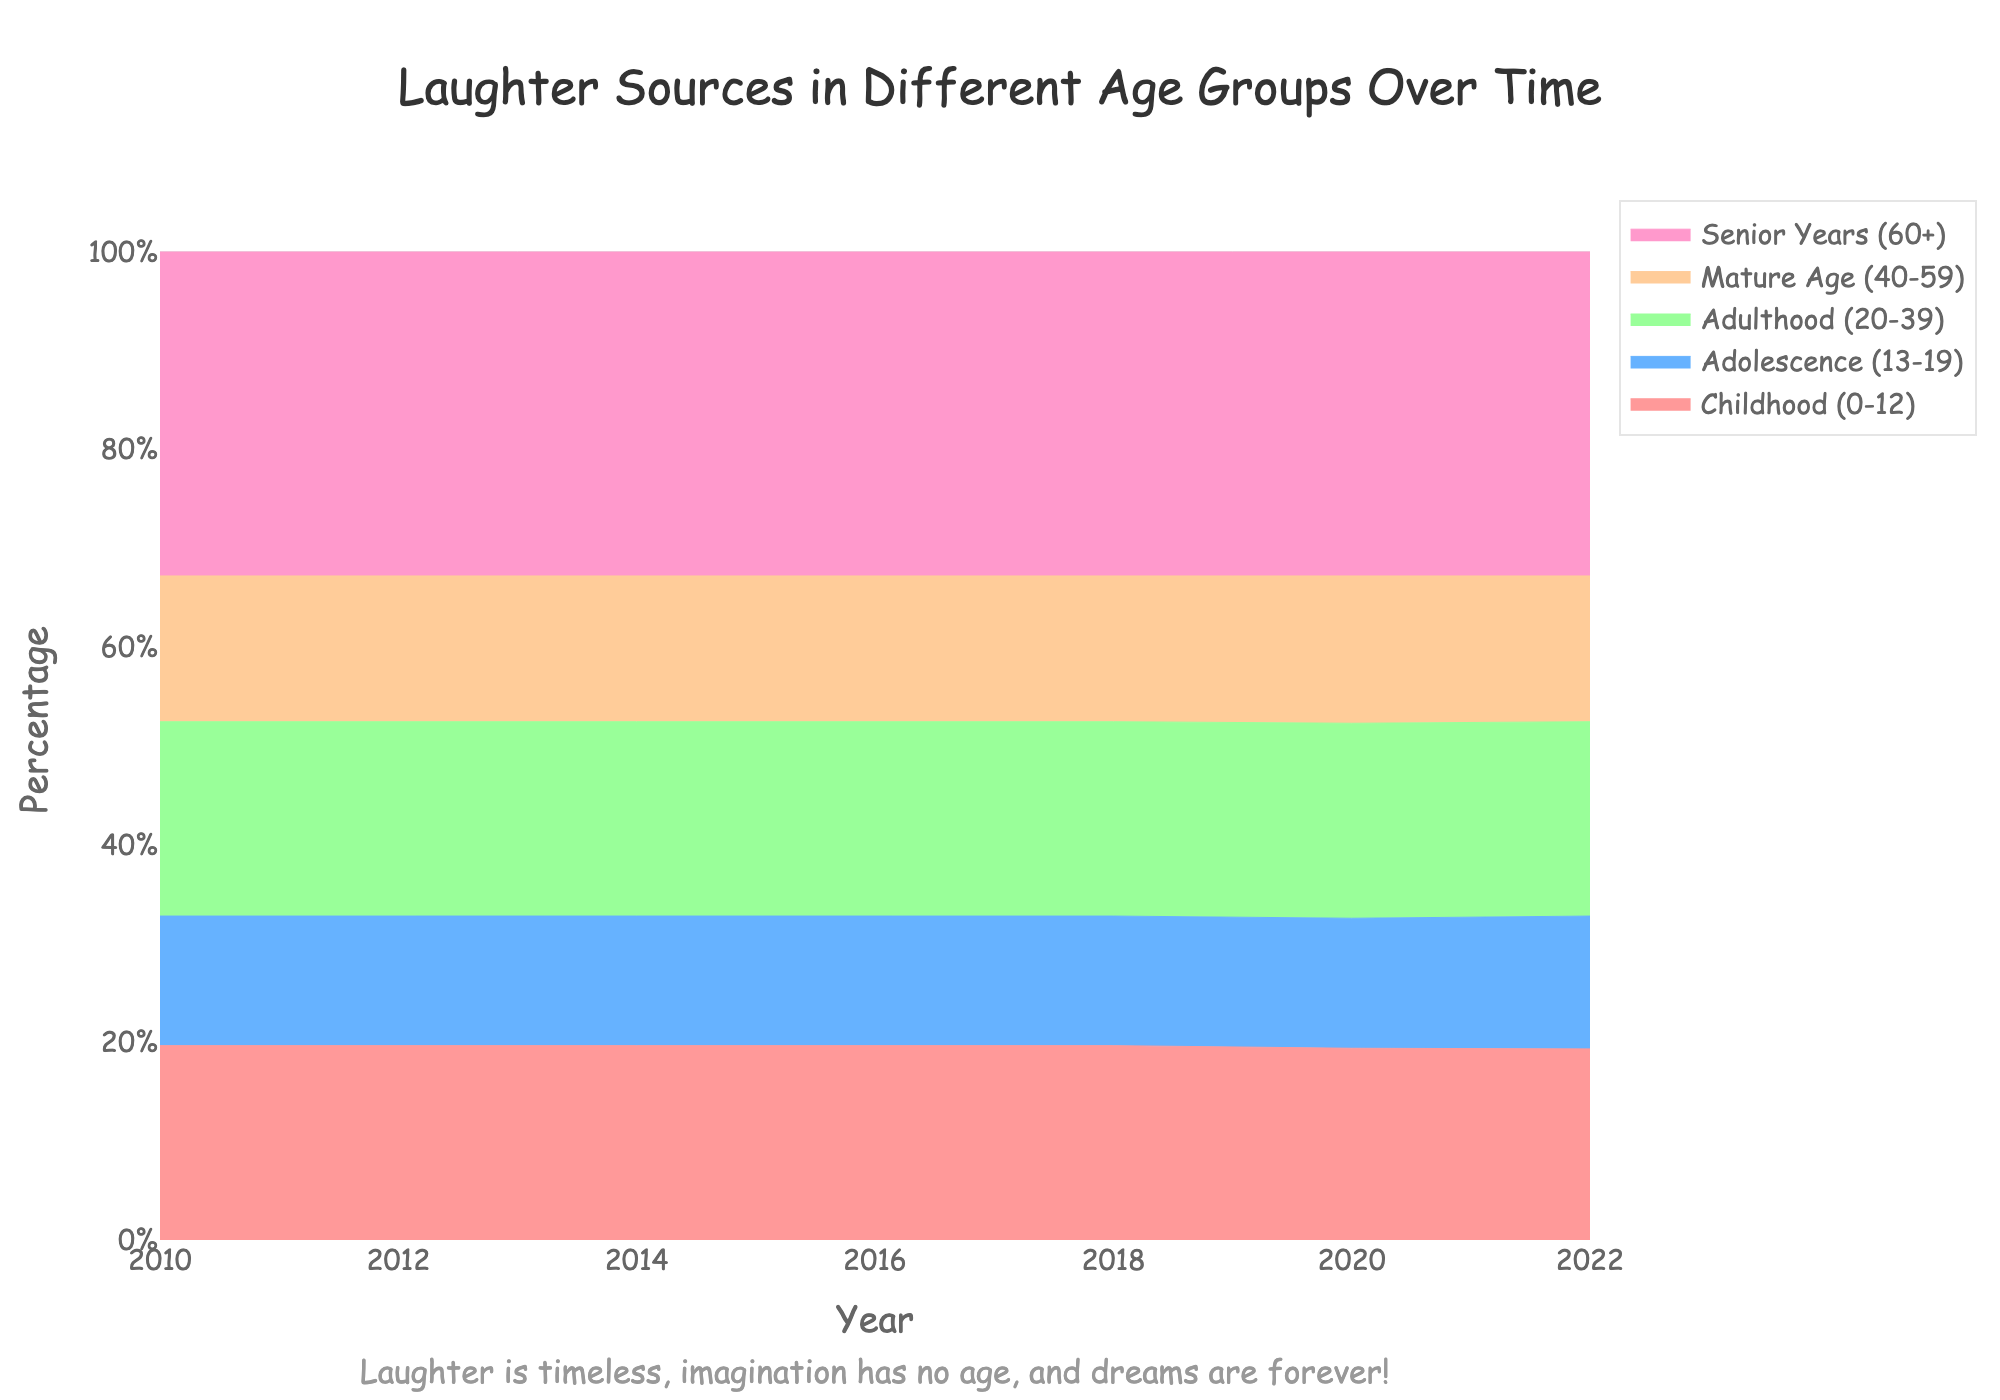What's the title of the chart? The title of the chart is written at the top center of the figure in larger font size and a unique color.
Answer: Laughter Sources in Different Age Groups Over Time What are the two sources of laughter for children aged 0-12? The sources of laughter for each age group are labeled in the legend and the chart colors correspond to the specific age groups.
Answer: Cartoons and School Friends By what percentage did laughter from "Workplace Humor" decrease in "Mature Age (40-59)" from 2010 to 2022? To find the percentage decrease, check the stacked area corresponding to "Workplace Humor" in "Mature Age (40-59)" for 2010 and 2022, and then calculate the difference.
Answer: 6% Which age group had the smallest percentage of laughter in 2014? Comparing all the stacked areas for 2014, identify the group with the smallest area.
Answer: Childhood (0-12) How has the percentage of laughter from "Stand-Up Comedy" in "Adulthood (20-39)" changed from 2010 to 2022? Examine the trend of the specific shaded area for "Stand-Up Comedy" in "Adulthood (20-39)" across the years 2010 to 2022 and describe it.
Answer: It increased from 30% to 40% What is the common trend observed for laughter sources in "Senior Years (60+)" from 2010 to 2022? Review the specific areas for "Classic Comedies" and "Social Gatherings" in "Senior Years (60+)" over time and summarize the trend.
Answer: They both generally increased Which sources of laughter have the most stability in percentage for "Adulthood (20-39)" between 2010 and 2022? Examine the percentages for different laughter sources within the age group "Adulthood (20-39)" and identify the one with the least variation over the years.
Answer: Sitcoms What is the overall trend for childhood laughter sources over the years? Analyze the combined shaded areas for "Cartoons" and "School Friends" in "Childhood (0-12)" across the timeline and describe the trend.
Answer: Decreasing In 2022, which two laughter sources are most dominant for "Senior Years (60+)"? Look at the specific areas for 2022 within the "Senior Years (60+)" age group and identify the sources with the largest portions.
Answer: Classic Comedies and Social Gatherings 